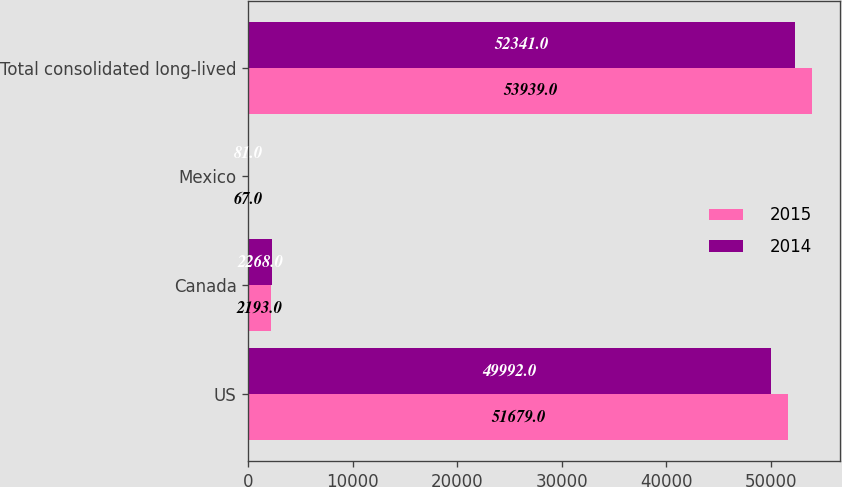Convert chart. <chart><loc_0><loc_0><loc_500><loc_500><stacked_bar_chart><ecel><fcel>US<fcel>Canada<fcel>Mexico<fcel>Total consolidated long-lived<nl><fcel>2015<fcel>51679<fcel>2193<fcel>67<fcel>53939<nl><fcel>2014<fcel>49992<fcel>2268<fcel>81<fcel>52341<nl></chart> 